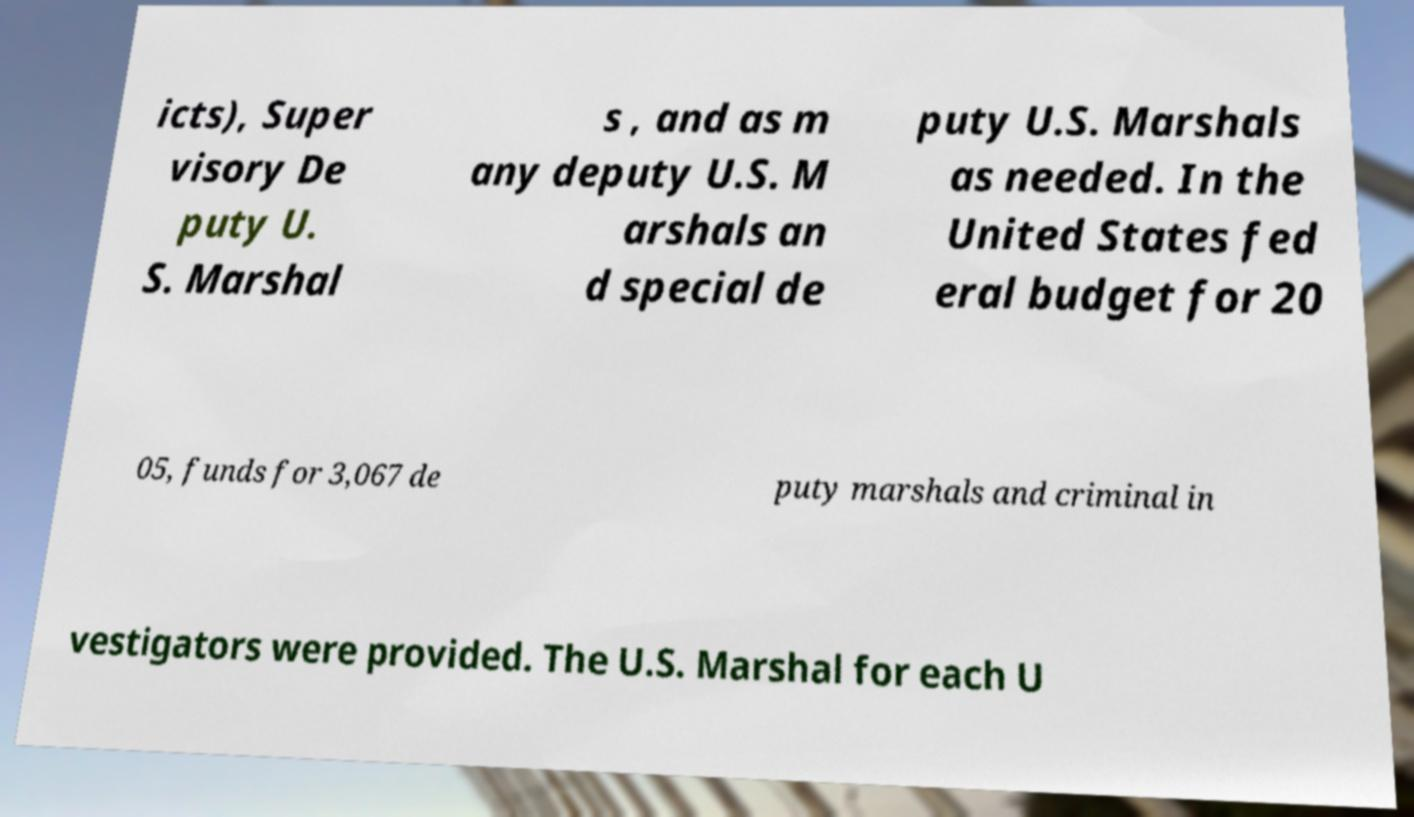What messages or text are displayed in this image? I need them in a readable, typed format. icts), Super visory De puty U. S. Marshal s , and as m any deputy U.S. M arshals an d special de puty U.S. Marshals as needed. In the United States fed eral budget for 20 05, funds for 3,067 de puty marshals and criminal in vestigators were provided. The U.S. Marshal for each U 